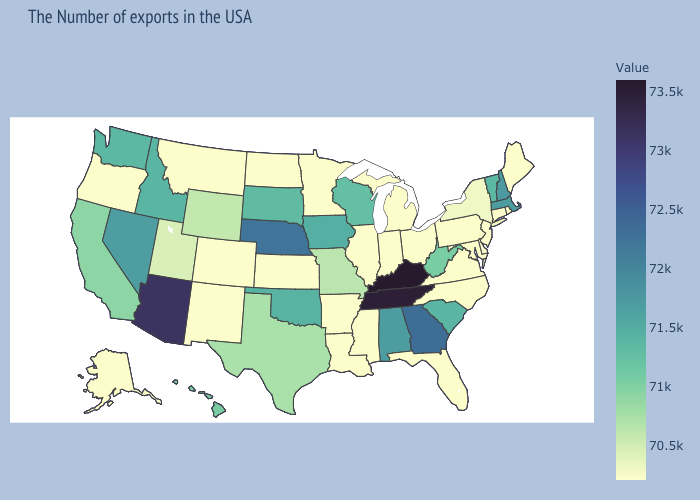Does New York have a higher value than Georgia?
Answer briefly. No. Among the states that border South Dakota , which have the highest value?
Give a very brief answer. Nebraska. Does Ohio have the lowest value in the MidWest?
Answer briefly. Yes. Which states have the lowest value in the USA?
Be succinct. Maine, Rhode Island, Connecticut, New Jersey, Delaware, Maryland, Pennsylvania, Virginia, North Carolina, Ohio, Florida, Michigan, Indiana, Illinois, Mississippi, Louisiana, Arkansas, Minnesota, Kansas, North Dakota, Colorado, New Mexico, Montana, Oregon, Alaska. Does Kansas have the lowest value in the USA?
Answer briefly. Yes. 